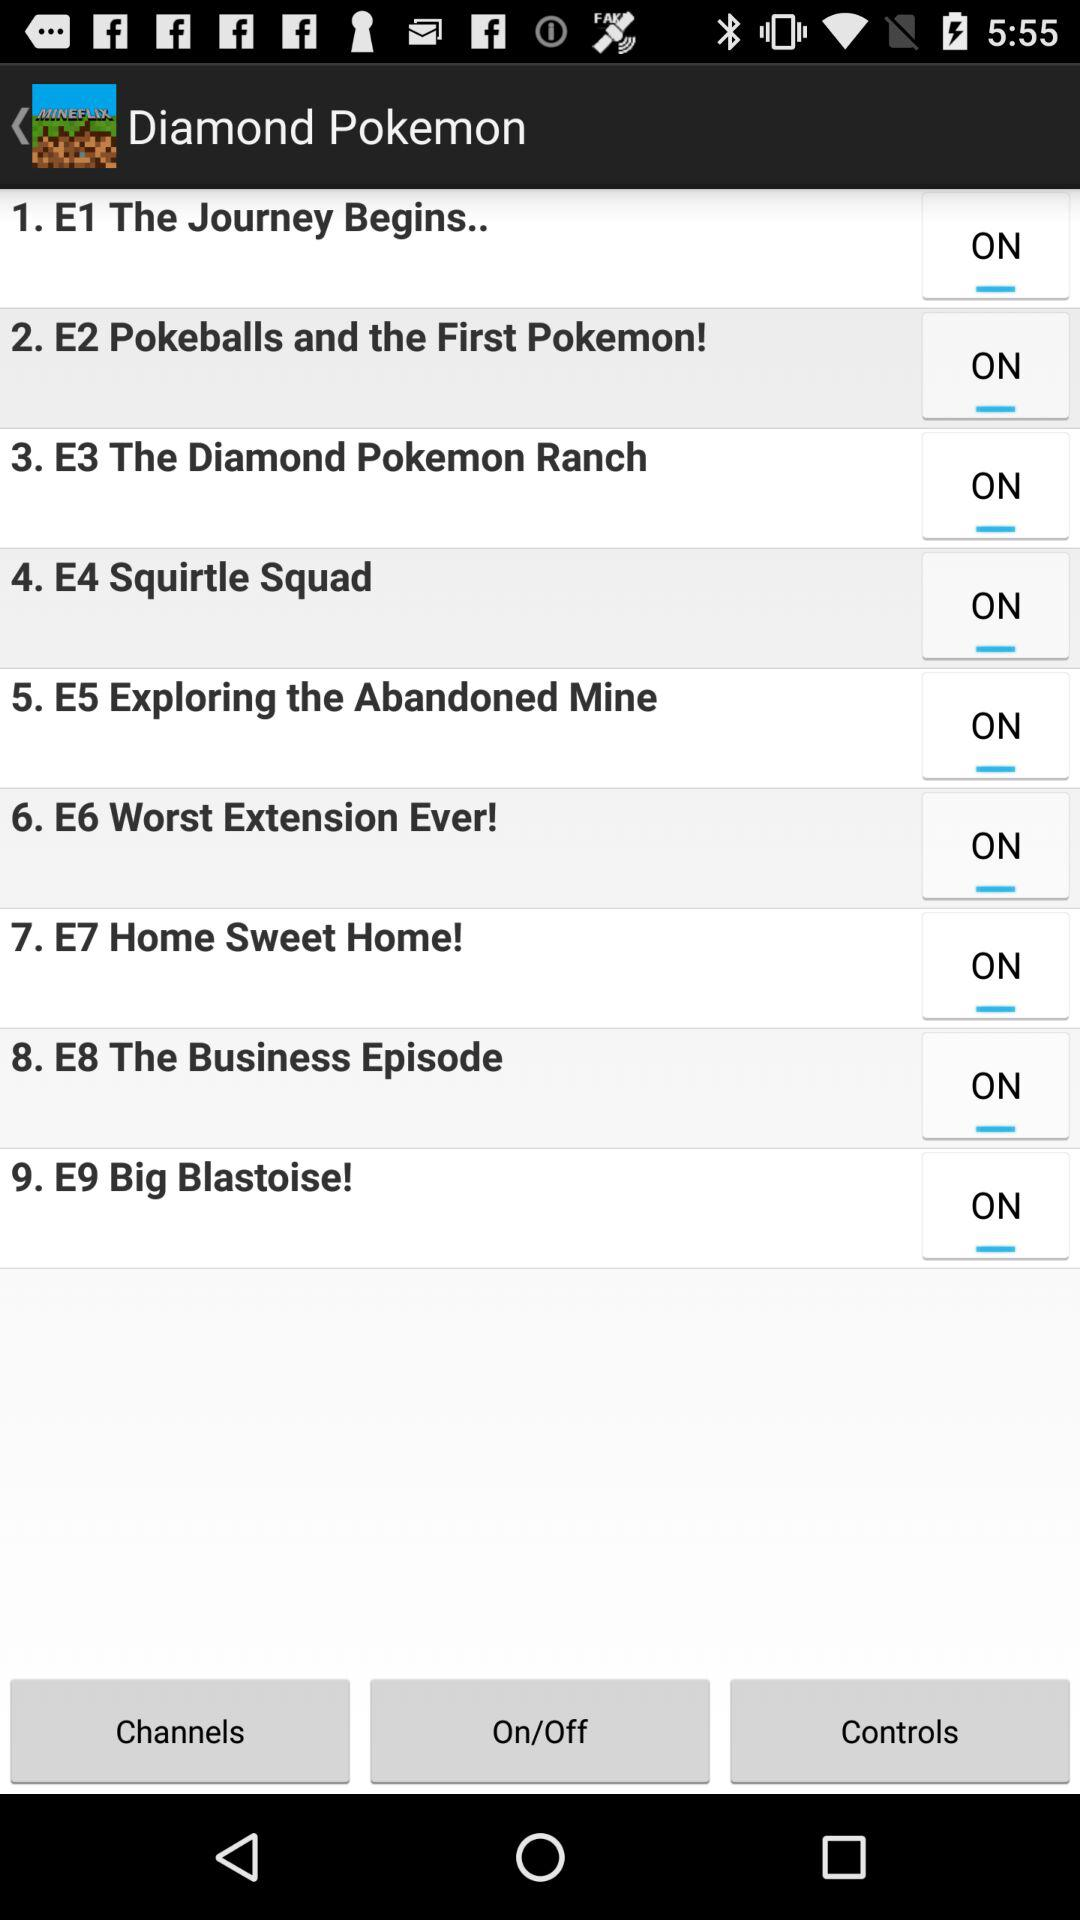Which is episode number 7? Episode number 7 is "Home Sweet Home!". 